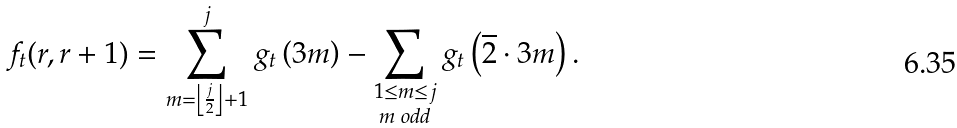Convert formula to latex. <formula><loc_0><loc_0><loc_500><loc_500>f _ { t } ( r , r + 1 ) = \sum _ { m = \left \lfloor \frac { j } { 2 } \right \rfloor + 1 } ^ { j } g _ { t } \left ( 3 m \right ) - \sum _ { \substack { 1 \leq m \leq j \\ m \text { odd} } } g _ { t } \left ( \overline { 2 } \cdot 3 m \right ) .</formula> 